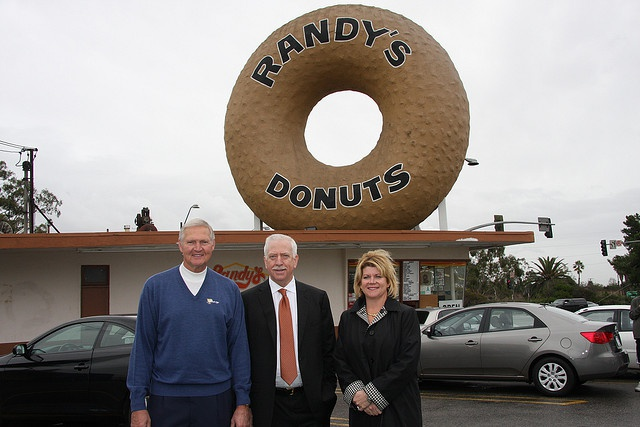Describe the objects in this image and their specific colors. I can see donut in white, gray, maroon, and black tones, people in white, navy, black, darkblue, and brown tones, car in white, black, darkgray, gray, and lightgray tones, people in white, black, brown, lightgray, and gray tones, and car in white, black, and gray tones in this image. 